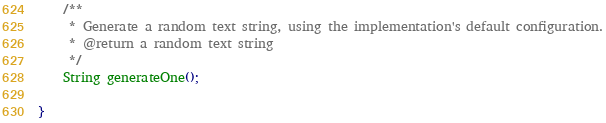Convert code to text. <code><loc_0><loc_0><loc_500><loc_500><_Java_>
    /**
     * Generate a random text string, using the implementation's default configuration.
     * @return a random text string
     */
    String generateOne();

}
</code> 